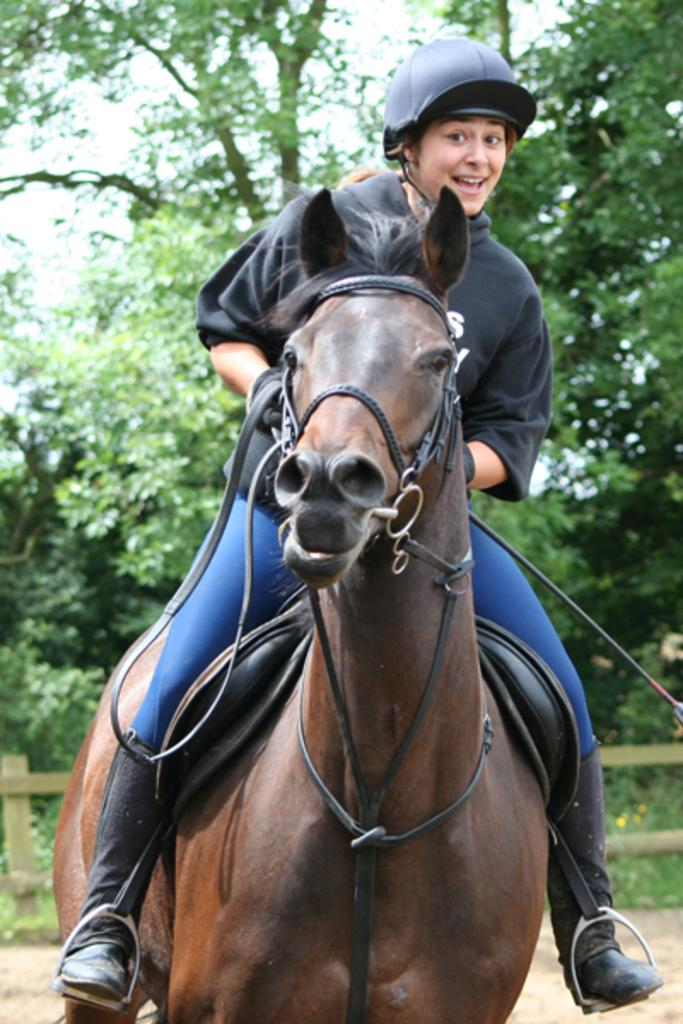Who is the main subject in the image? There is a lady in the image. What is the lady doing in the image? The lady is sitting on a horse. What type of clothing is the lady wearing? The lady is wearing a coat, helmet, and gloves. What object is the lady holding in the image? The lady is holding a belt. What can be seen in the background of the image? There are trees and a fence visible in the background of the image. What type of card is the lady holding in the image? There is no card present in the image; the lady is holding a belt. Is the lady wearing a mask in the image? No, the lady is not wearing a mask in the image; she is wearing a helmet. 